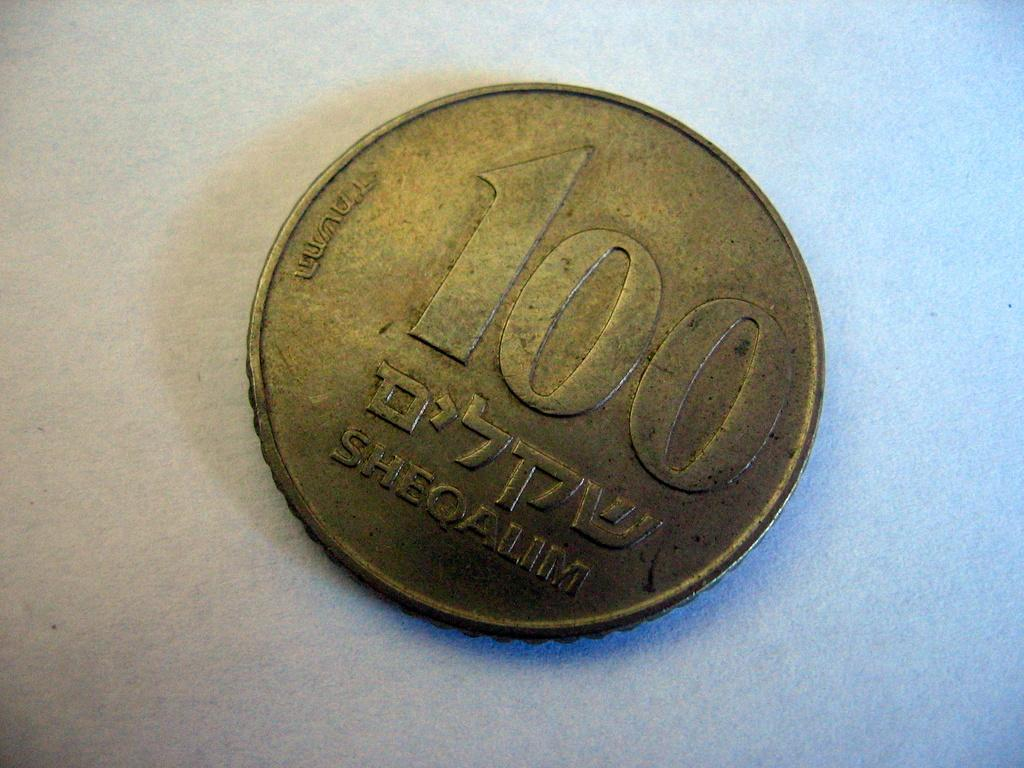Provide a one-sentence caption for the provided image. a 100 Sheoalim bronze coin on white background. 